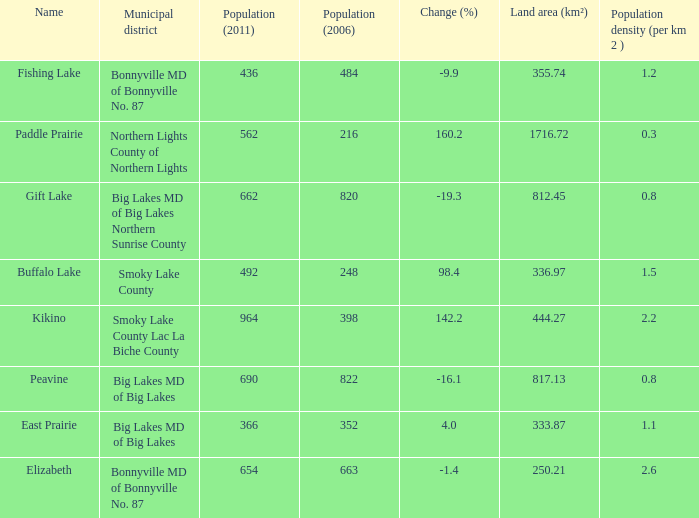What place is there a change of -19.3? 1.0. 